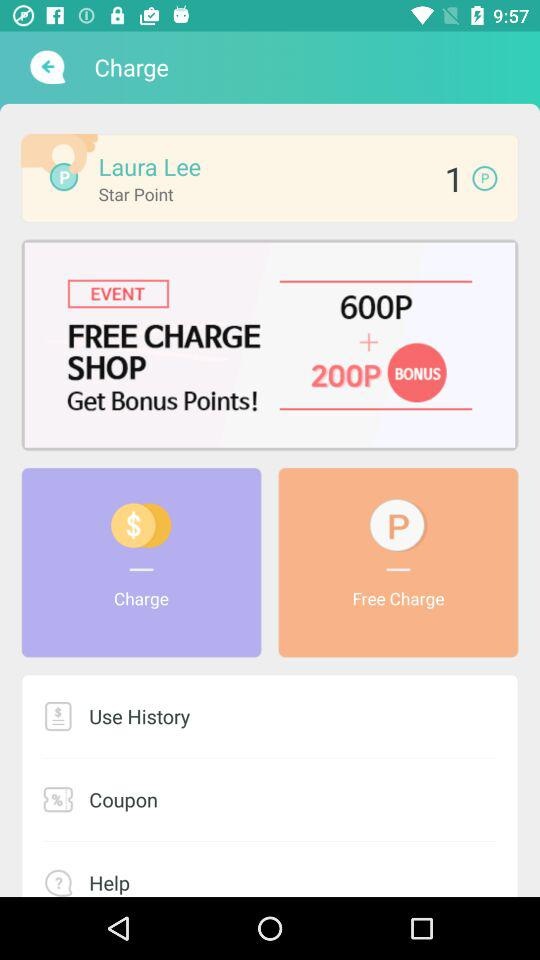What is the name? The name is Laura Lee. 